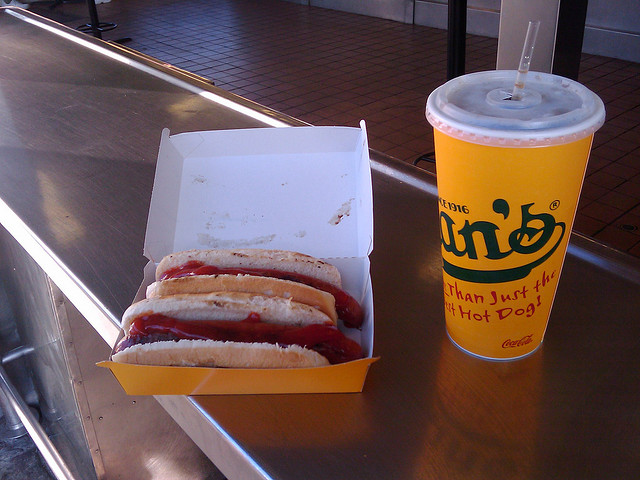Identify the text contained in this image. &#174; JUST the HOT Dog Than 